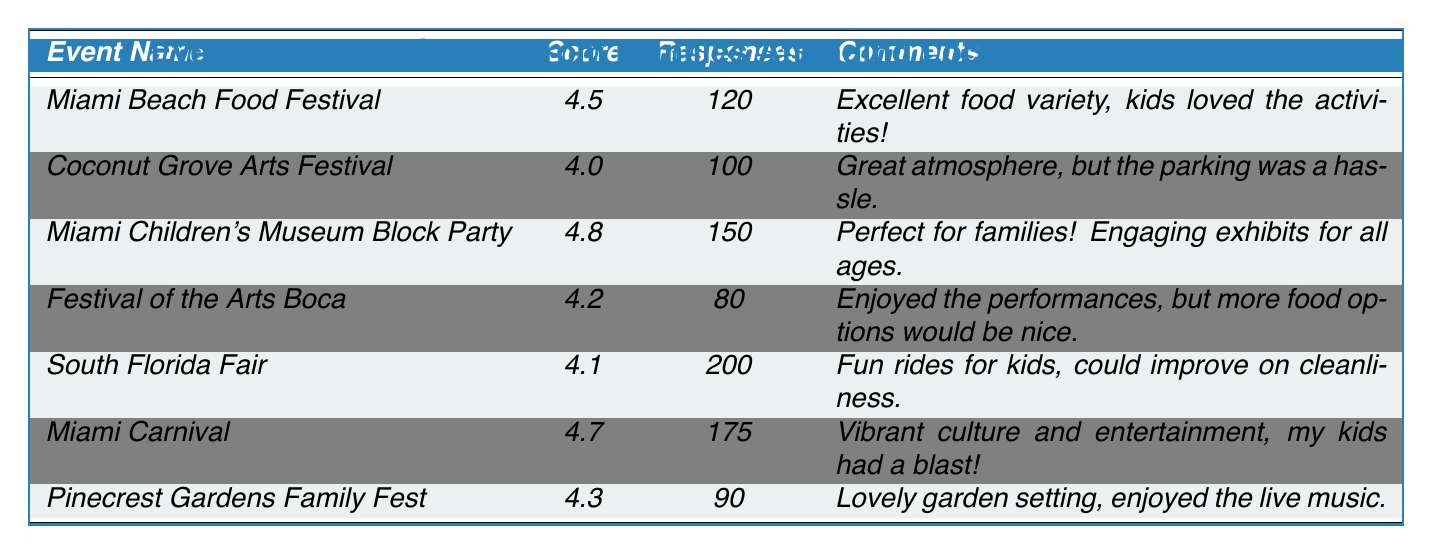What is the highest family feedback score among the events? The family feedback scores listed in the table are 4.5, 4.0, 4.8, 4.2, 4.1, 4.7, and 4.3. The highest of these scores is 4.8 from the Miami Children's Museum Block Party.
Answer: 4.8 How many total responses were collected across all events? The number of responses for each event is 120, 100, 150, 80, 200, 175, and 90. Summing these gives 120 + 100 + 150 + 80 + 200 + 175 + 90 = 1,015.
Answer: 1,015 Which event had the least number of responses? The number of responses for the events are 120, 100, 150, 80, 200, 175, and 90. The event with the least responses is the Festival of the Arts Boca with 80 responses.
Answer: Festival of the Arts Boca Is the comment for the Miami Carnival positive or negative? The comment states "Vibrant culture and entertainment, my kids had a blast!" which indicates a positive sentiment about the event.
Answer: Positive What is the average feedback score of the events listed? The feedback scores are 4.5, 4.0, 4.8, 4.2, 4.1, 4.7, and 4.3. To find the average, sum these scores (4.5 + 4.0 + 4.8 + 4.2 + 4.1 + 4.7 + 4.3 = 26.6) and divide by the number of events (7), which gives an average score of 26.6 / 7 ≈ 3.8.
Answer: Approximately 3.8 How many more responses did the South Florida Fair receive compared to the Pinecrest Gardens Family Fest? The South Florida Fair received 200 responses, while the Pinecrest Gardens Family Fest received 90 responses. The difference in responses is 200 - 90 = 110.
Answer: 110 Which event received 4.3 as a feedback score? Referring to the table, the event with a feedback score of 4.3 is Pinecrest Gardens Family Fest.
Answer: Pinecrest Gardens Family Fest Did more families prefer the Miami Children's Museum Block Party compared to the Coconut Grove Arts Festival? The Miami Children's Museum Block Party had 150 responses with a score of 4.8, while the Coconut Grove Arts Festival had 100 responses with a score of 4.0. Since the number of families responding was higher for the Block Party, we can conclude that it was preferred more.
Answer: Yes What percentage of respondents rated the Miami Beach Food Festival above 4? The Miami Beach Food Festival received a score of 4.5 from 120 responses, which means all respondents rated it above 4. Therefore, the percentage is 120 / 120 * 100 = 100%.
Answer: 100% 